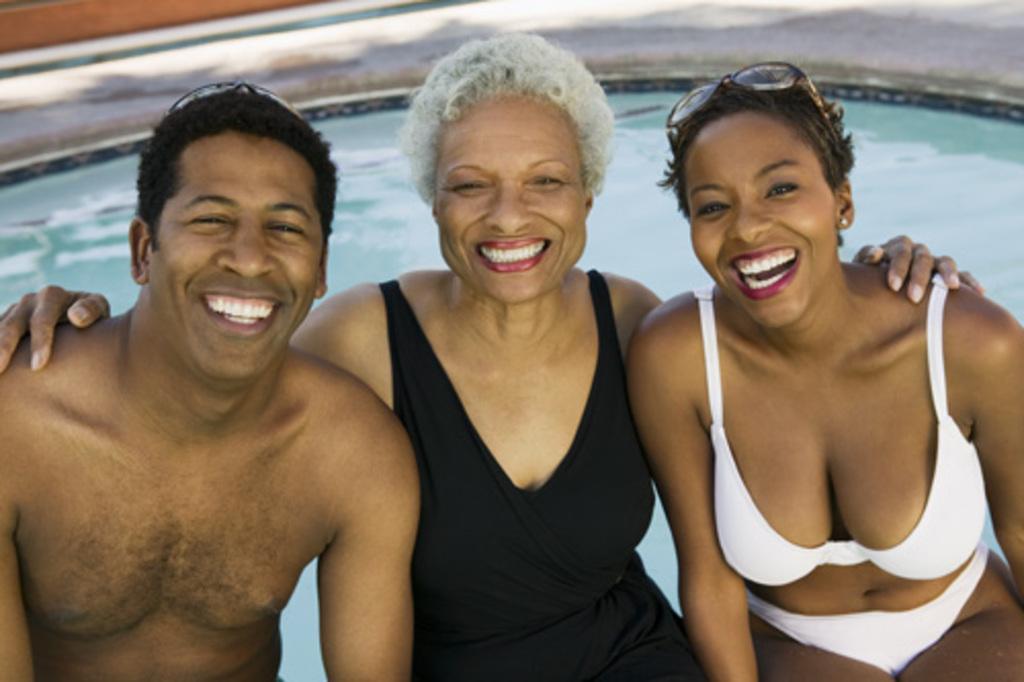How many people are in the image? There are three persons in the image. What can be seen behind the persons? There is water visible behind the persons. What page of the book are the persons reading in the image? There is no book present in the image, so it is not possible to determine which page they might be reading. 